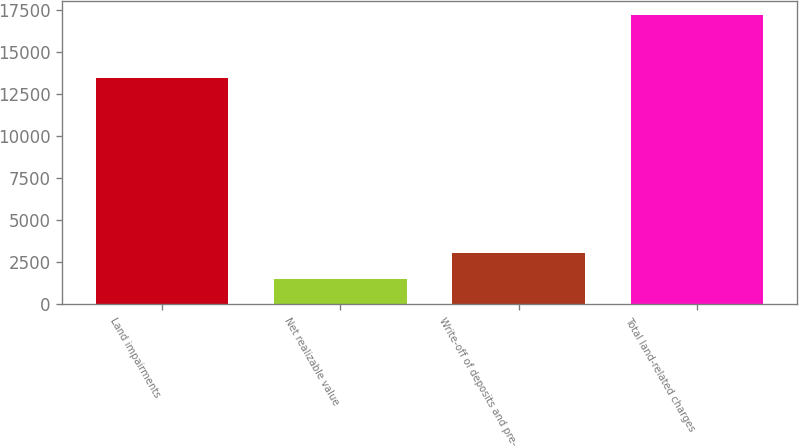<chart> <loc_0><loc_0><loc_500><loc_500><bar_chart><fcel>Land impairments<fcel>Net realizable value<fcel>Write-off of deposits and pre-<fcel>Total land-related charges<nl><fcel>13437<fcel>1480<fcel>3051.5<fcel>17195<nl></chart> 